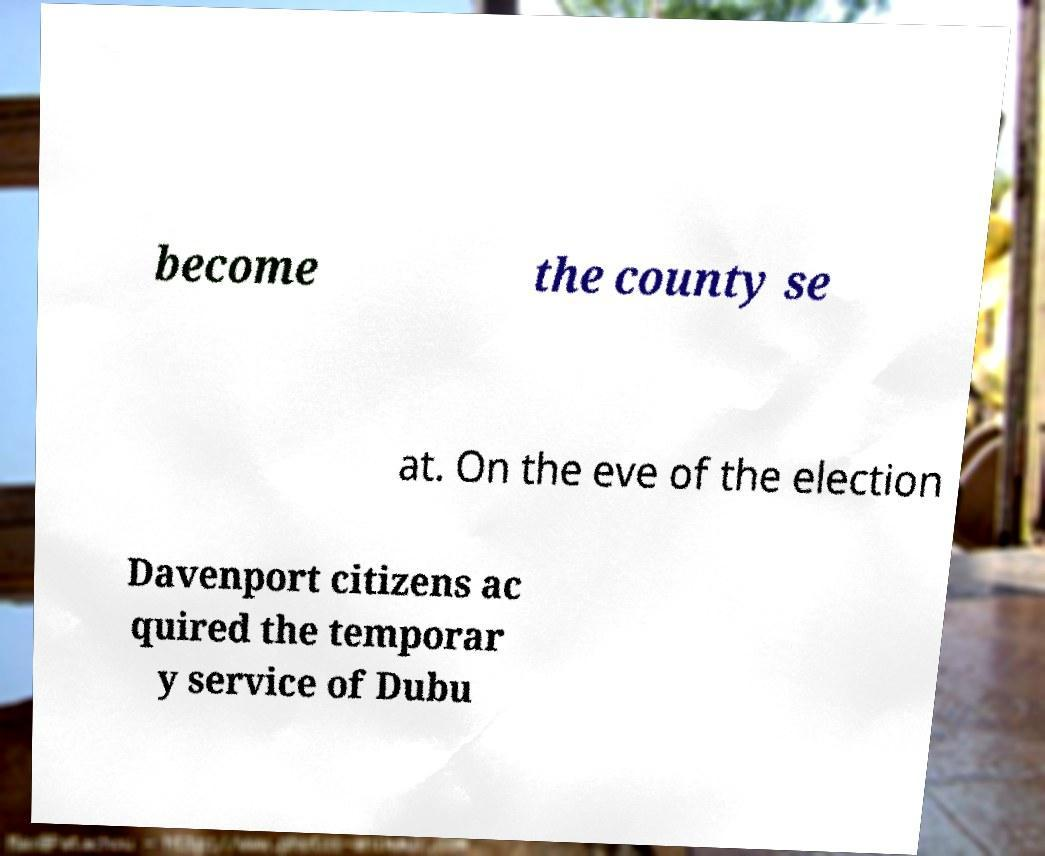Please read and relay the text visible in this image. What does it say? become the county se at. On the eve of the election Davenport citizens ac quired the temporar y service of Dubu 